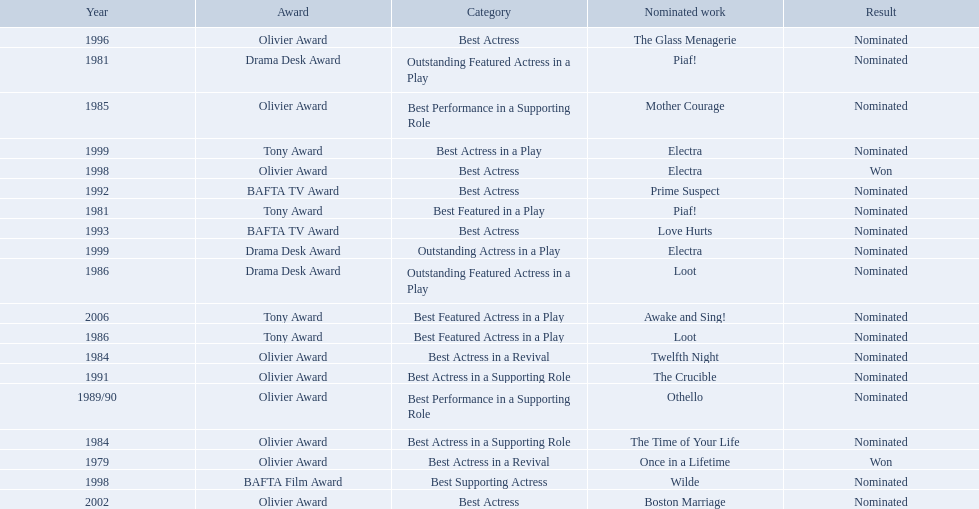Write the full table. {'header': ['Year', 'Award', 'Category', 'Nominated work', 'Result'], 'rows': [['1996', 'Olivier Award', 'Best Actress', 'The Glass Menagerie', 'Nominated'], ['1981', 'Drama Desk Award', 'Outstanding Featured Actress in a Play', 'Piaf!', 'Nominated'], ['1985', 'Olivier Award', 'Best Performance in a Supporting Role', 'Mother Courage', 'Nominated'], ['1999', 'Tony Award', 'Best Actress in a Play', 'Electra', 'Nominated'], ['1998', 'Olivier Award', 'Best Actress', 'Electra', 'Won'], ['1992', 'BAFTA TV Award', 'Best Actress', 'Prime Suspect', 'Nominated'], ['1981', 'Tony Award', 'Best Featured in a Play', 'Piaf!', 'Nominated'], ['1993', 'BAFTA TV Award', 'Best Actress', 'Love Hurts', 'Nominated'], ['1999', 'Drama Desk Award', 'Outstanding Actress in a Play', 'Electra', 'Nominated'], ['1986', 'Drama Desk Award', 'Outstanding Featured Actress in a Play', 'Loot', 'Nominated'], ['2006', 'Tony Award', 'Best Featured Actress in a Play', 'Awake and Sing!', 'Nominated'], ['1986', 'Tony Award', 'Best Featured Actress in a Play', 'Loot', 'Nominated'], ['1984', 'Olivier Award', 'Best Actress in a Revival', 'Twelfth Night', 'Nominated'], ['1991', 'Olivier Award', 'Best Actress in a Supporting Role', 'The Crucible', 'Nominated'], ['1989/90', 'Olivier Award', 'Best Performance in a Supporting Role', 'Othello', 'Nominated'], ['1984', 'Olivier Award', 'Best Actress in a Supporting Role', 'The Time of Your Life', 'Nominated'], ['1979', 'Olivier Award', 'Best Actress in a Revival', 'Once in a Lifetime', 'Won'], ['1998', 'BAFTA Film Award', 'Best Supporting Actress', 'Wilde', 'Nominated'], ['2002', 'Olivier Award', 'Best Actress', 'Boston Marriage', 'Nominated']]} Which works were nominated for the oliver award? Twelfth Night, The Time of Your Life, Mother Courage, Othello, The Crucible, The Glass Menagerie, Electra, Boston Marriage. Of these which ones did not win? Twelfth Night, The Time of Your Life, Mother Courage, Othello, The Crucible, The Glass Menagerie, Boston Marriage. Which of those were nominated for best actress of any kind in the 1080s? Twelfth Night, The Time of Your Life. Which of these was a revival? Twelfth Night. 